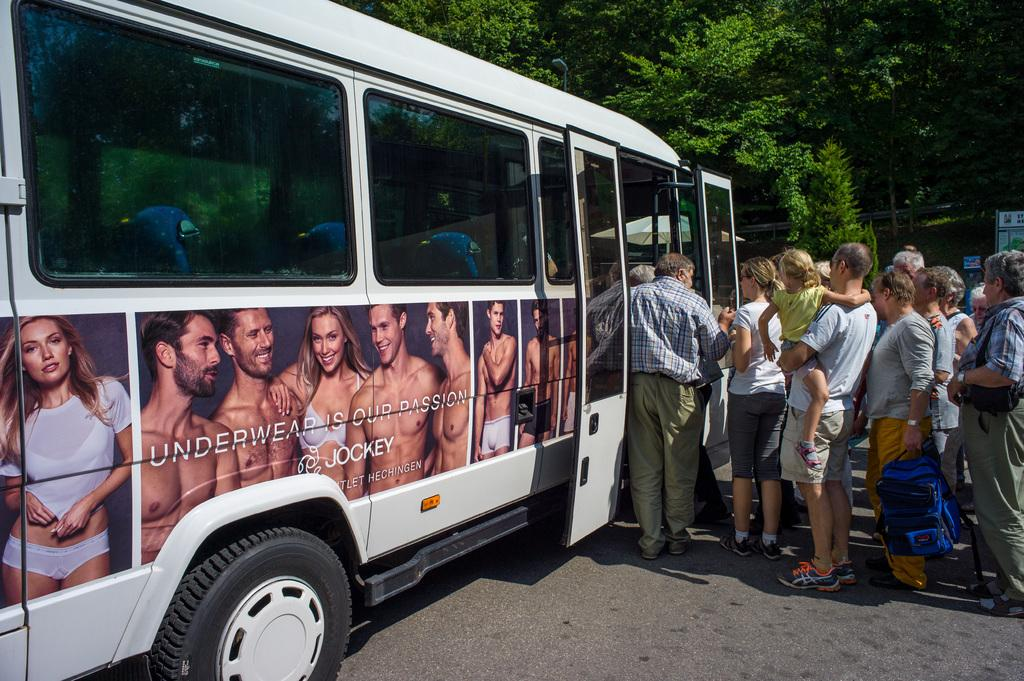<image>
Write a terse but informative summary of the picture. people load onto a bus that has a Jockey ad on the side 